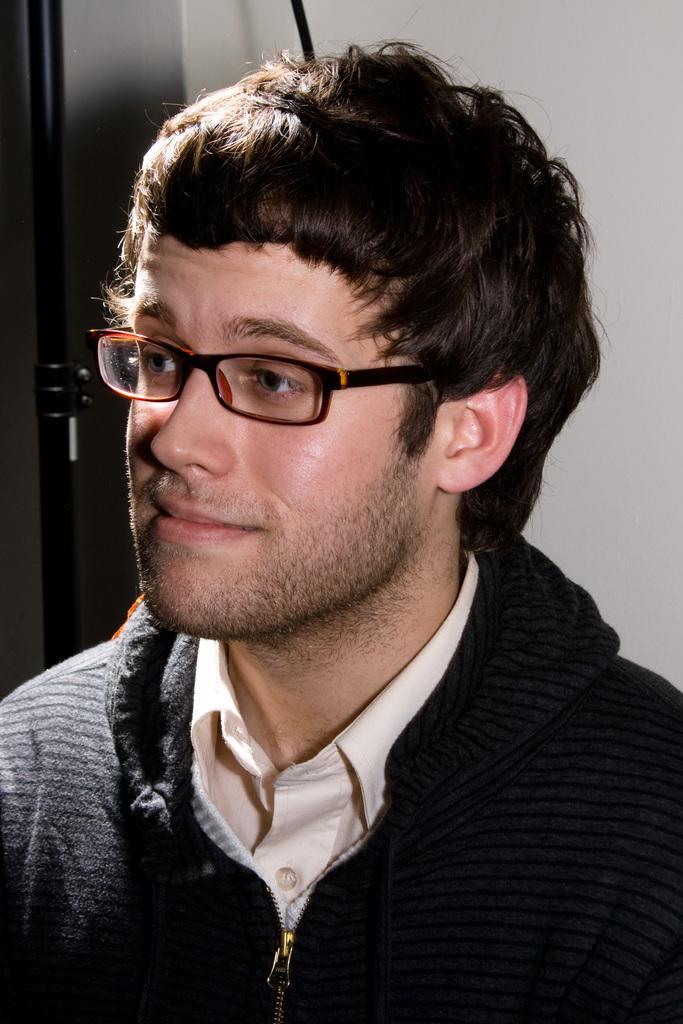Could you give a brief overview of what you see in this image? In this image I can see a man wearing specs and a black color of jacket. In the background I can see white and a door. 